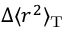Convert formula to latex. <formula><loc_0><loc_0><loc_500><loc_500>\Delta \langle r ^ { 2 } \rangle _ { T }</formula> 